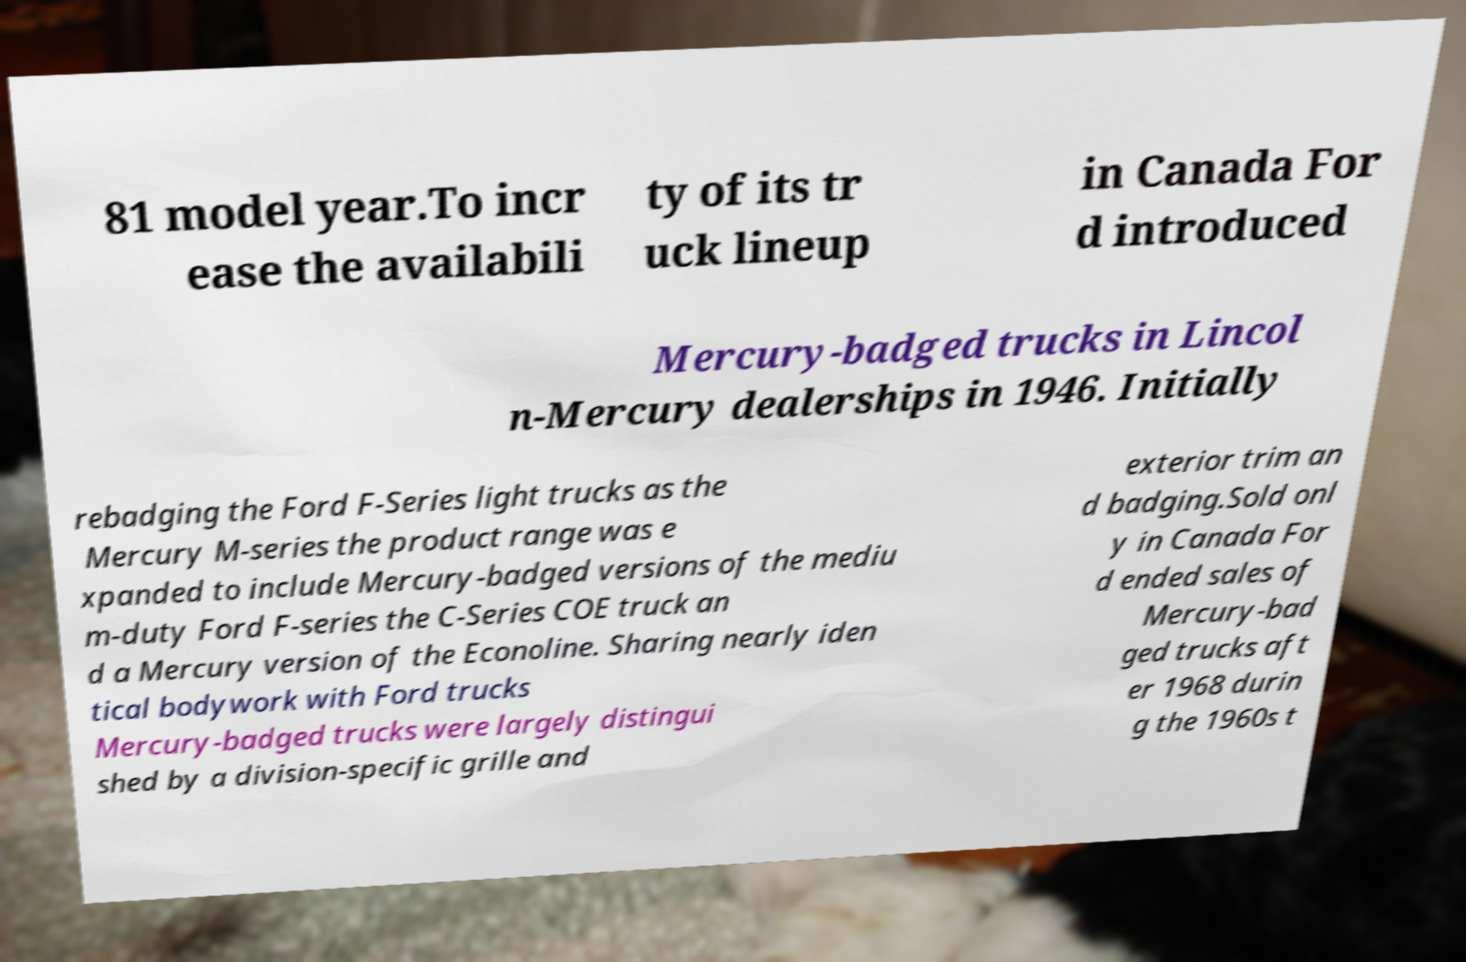Can you accurately transcribe the text from the provided image for me? 81 model year.To incr ease the availabili ty of its tr uck lineup in Canada For d introduced Mercury-badged trucks in Lincol n-Mercury dealerships in 1946. Initially rebadging the Ford F-Series light trucks as the Mercury M-series the product range was e xpanded to include Mercury-badged versions of the mediu m-duty Ford F-series the C-Series COE truck an d a Mercury version of the Econoline. Sharing nearly iden tical bodywork with Ford trucks Mercury-badged trucks were largely distingui shed by a division-specific grille and exterior trim an d badging.Sold onl y in Canada For d ended sales of Mercury-bad ged trucks aft er 1968 durin g the 1960s t 